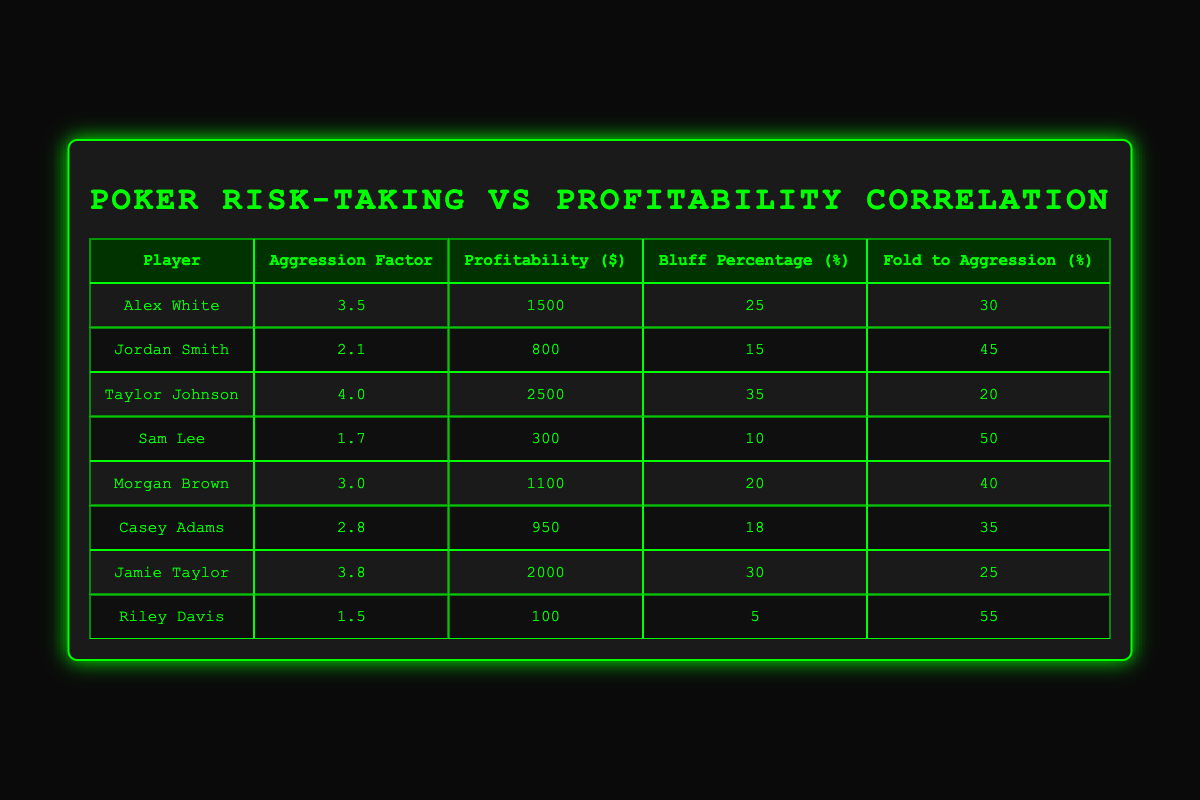What is the highest profitability among the players? Looking at the "Profitability ($)" column, the highest number is 2500, which belongs to Taylor Johnson.
Answer: 2500 Which player has the lowest aggression factor? By examining the "Aggression Factor" column, the lowest value is 1.5, which corresponds to Riley Davis.
Answer: Riley Davis Is it true that Jordan Smith has a higher bluff percentage than Alex White? Comparing the bluff percentages from both players, Jordan Smith has a bluff percentage of 15%, while Alex White has 25%. Therefore, the statement is false.
Answer: No What is the correlation between aggression factor and profitability based on the top three players? The top three players by profitability are Taylor Johnson (4.0, 2500), Jamie Taylor (3.8, 2000), and Alex White (3.5, 1500). Their aggression factors are 4.0, 3.8, and 3.5 respectively, which indicates a positive correlation since profitability increases with higher aggression factors.
Answer: Positive correlation What is the average fold to aggression percentage for all players in the table? The fold to aggression percentages are 30, 45, 20, 50, 40, 35, 25, and 55. Summing these values gives 300, then dividing by 8 (the number of players) results in an average of 37.5.
Answer: 37.5 